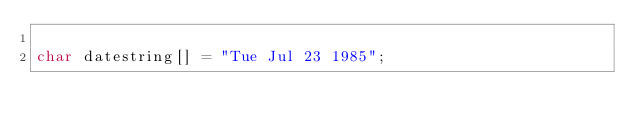<code> <loc_0><loc_0><loc_500><loc_500><_C_>
char datestring[] = "Tue Jul 23 1985";
</code> 